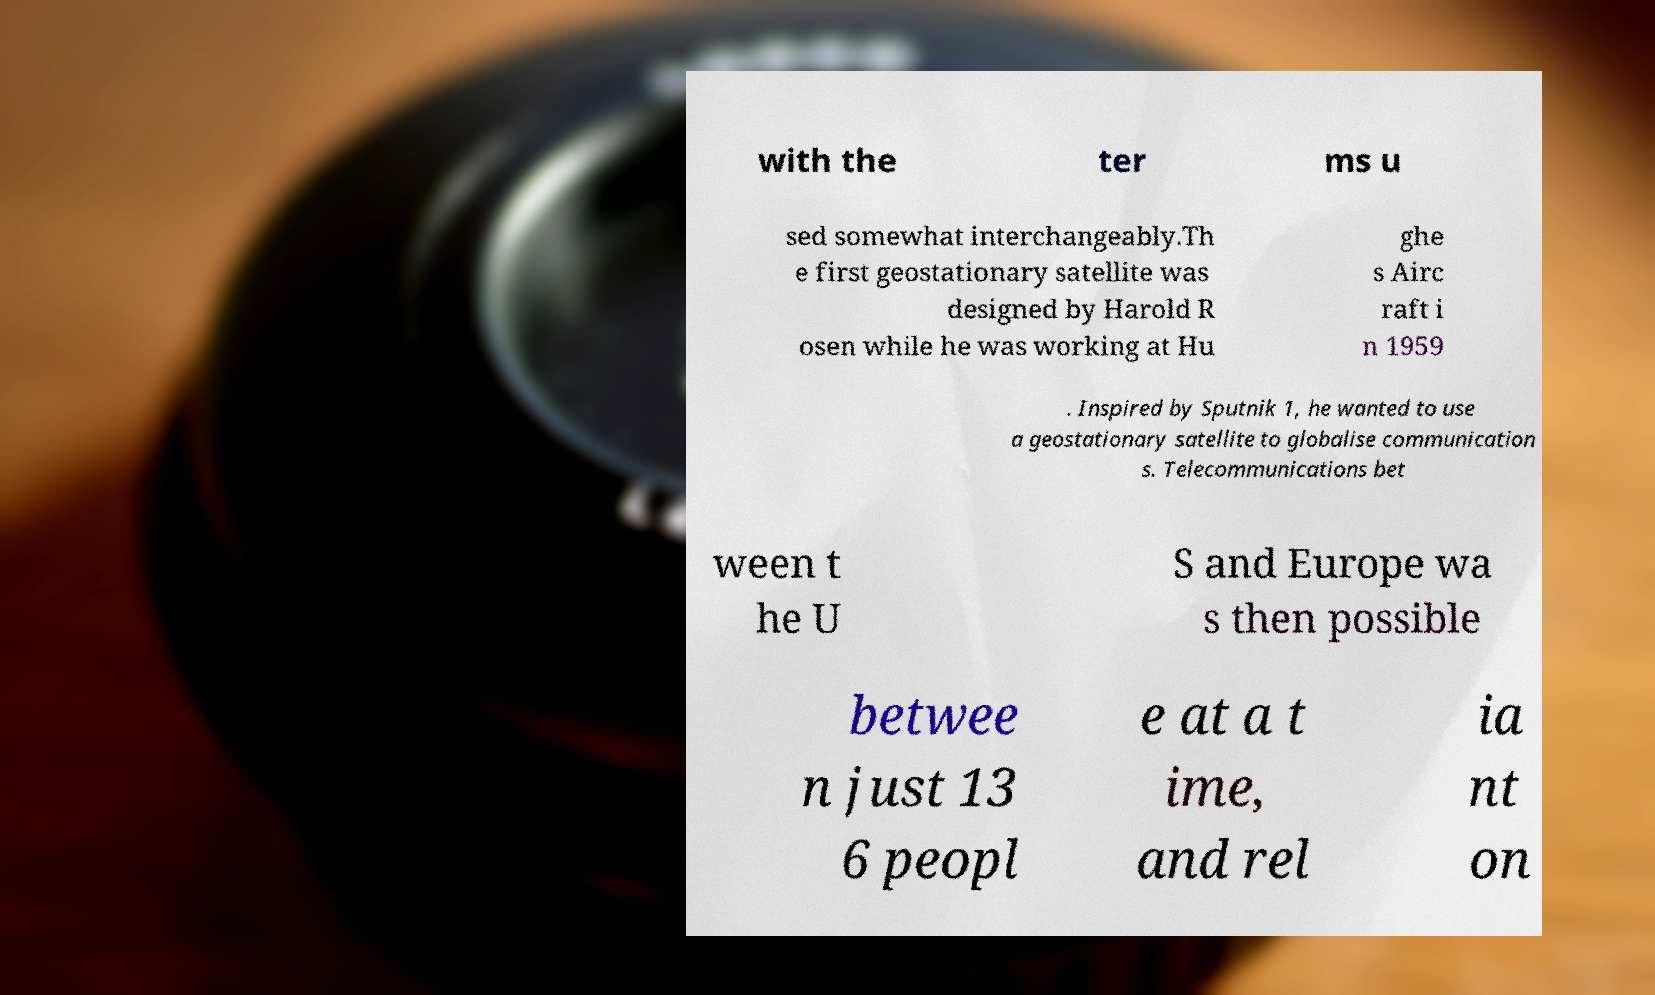Please read and relay the text visible in this image. What does it say? with the ter ms u sed somewhat interchangeably.Th e first geostationary satellite was designed by Harold R osen while he was working at Hu ghe s Airc raft i n 1959 . Inspired by Sputnik 1, he wanted to use a geostationary satellite to globalise communication s. Telecommunications bet ween t he U S and Europe wa s then possible betwee n just 13 6 peopl e at a t ime, and rel ia nt on 